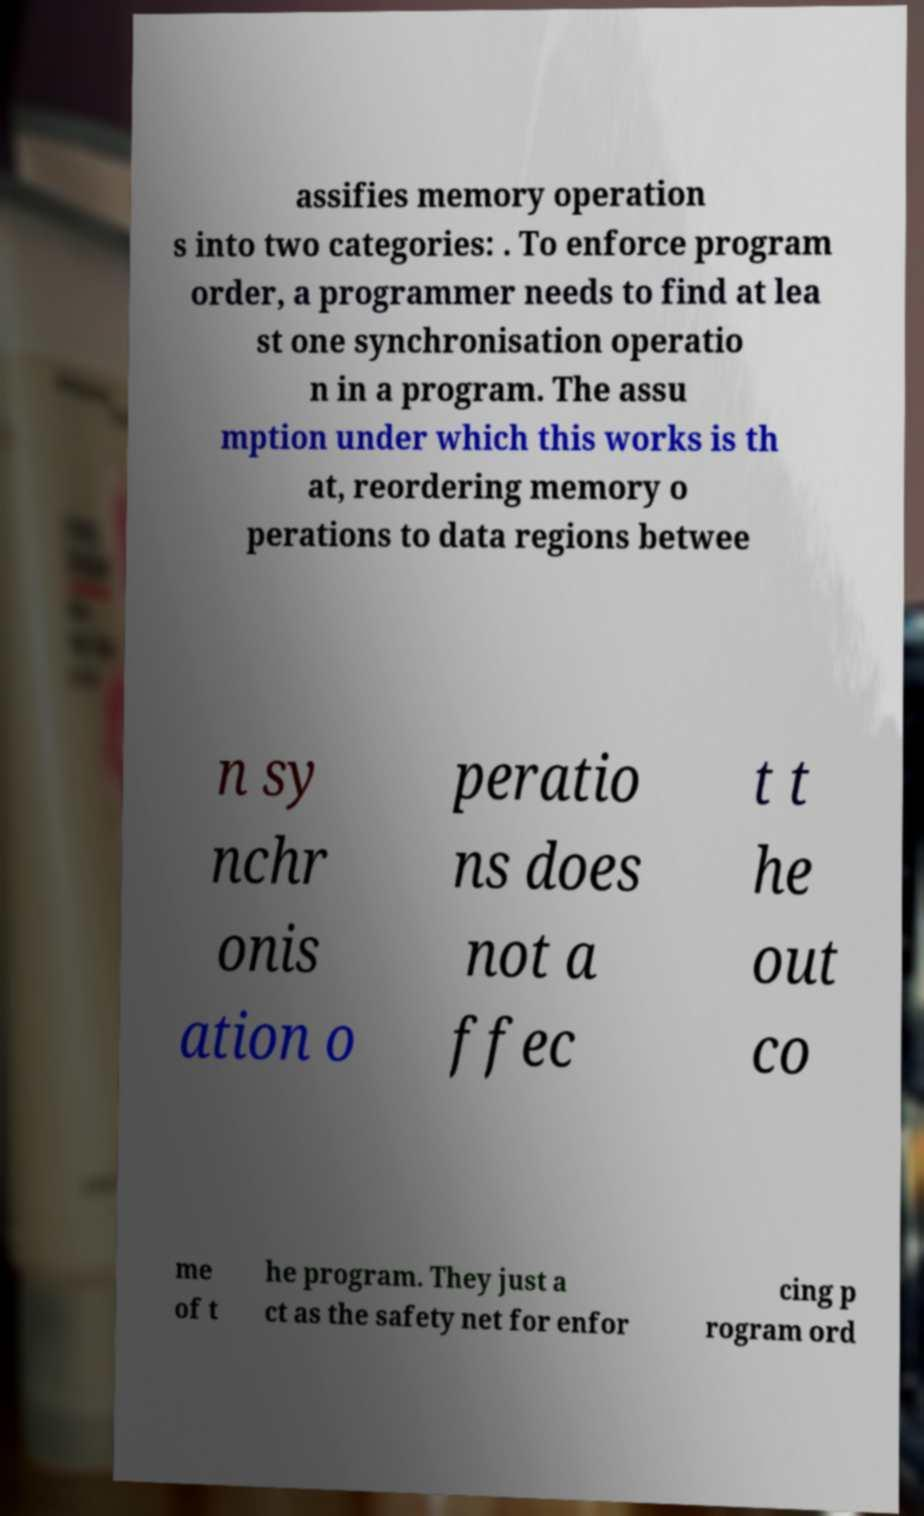I need the written content from this picture converted into text. Can you do that? assifies memory operation s into two categories: . To enforce program order, a programmer needs to find at lea st one synchronisation operatio n in a program. The assu mption under which this works is th at, reordering memory o perations to data regions betwee n sy nchr onis ation o peratio ns does not a ffec t t he out co me of t he program. They just a ct as the safety net for enfor cing p rogram ord 